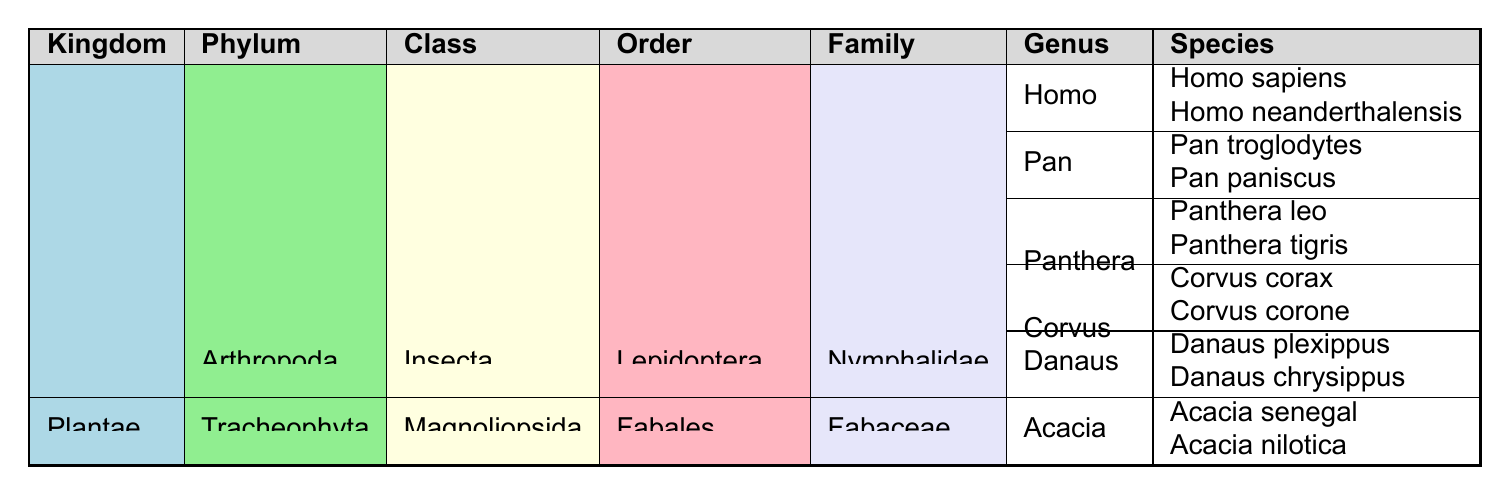What kingdoms are represented in the table? The table lists two kingdoms: Animalia and Plantae.
Answer: Animalia, Plantae How many species are listed under the genus Homo? The genus Homo includes two species: Homo sapiens and Homo neanderthalensis.
Answer: 2 Which family contains the species Panthera leo? Panthera leo is listed under the family Felidae.
Answer: Felidae Are there more species listed in the genus Corvus than in the genus Danaus? The genus Corvus has two species (Corvus corax and Corvus corone) while the genus Danaus also has two species (Danaus plexippus and Danaus chrysippus), so they are equal.
Answer: Yes, they are equal Which class has the most orders listed in the table? In the class Mammalia, there are two orders (Primates and Carnivora), whereas Aves has only one order and Insecta has one order. Therefore, Mammalia has the most orders.
Answer: Mammalia How many families are present under the order Lepidoptera? There is one family listed, which is Nymphalidae, under the order Lepidoptera.
Answer: 1 Which species belongs to the genus Pan? The genus Pan includes the species Pan troglodytes and Pan paniscus.
Answer: Pan troglodytes, Pan paniscus Is Acacia a genus under the family Nymphalidae? No, Acacia is a genus under the family Fabaceae, while Nymphalidae is a family under the order Lepidoptera.
Answer: No How many genera are represented under the family Corvidae? There is one genus listed under the family Corvidae, which is Corvus.
Answer: 1 List all species found under the family Hominidae. The family Hominidae includes two species: Homo sapiens and Homo neanderthalensis.
Answer: Homo sapiens, Homo neanderthalensis Which phylum is represented by the class Insecta? The class Insecta is represented under the phylum Arthropoda.
Answer: Arthropoda Which kingdom has the most classes listed? The kingdom Animalia has four classes listed (Mammalia, Aves, Insecta) compared to Plantae, which has one. Thus, Animalia has the most.
Answer: Animalia How many species of the genus Acacia are listed in the table? There are two species listed under the genus Acacia: Acacia senegal and Acacia nilotica.
Answer: 2 What is the relationship between the class Mammalia and the order Carnivora? The class Mammalia includes the order Carnivora as one of its subsets.
Answer: Class includes Order Are there any species under the family Fabaceae? Yes, the family Fabaceae has two species listed under the genus Acacia.
Answer: Yes 